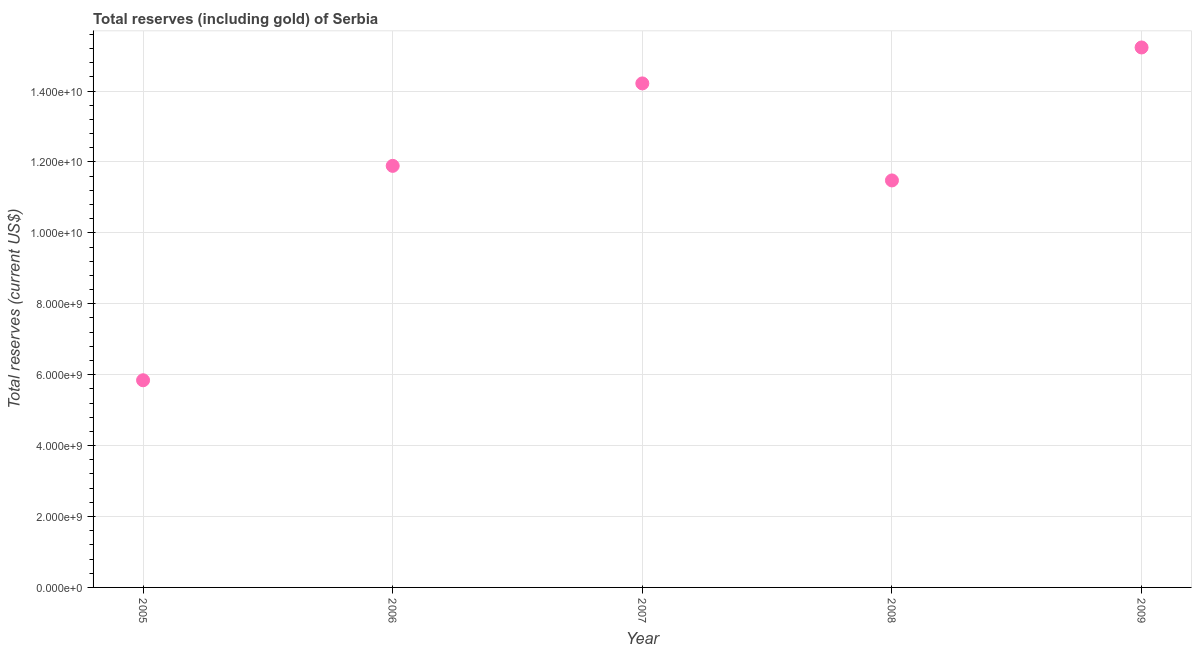What is the total reserves (including gold) in 2008?
Ensure brevity in your answer.  1.15e+1. Across all years, what is the maximum total reserves (including gold)?
Your answer should be very brief. 1.52e+1. Across all years, what is the minimum total reserves (including gold)?
Your answer should be very brief. 5.84e+09. What is the sum of the total reserves (including gold)?
Offer a terse response. 5.87e+1. What is the difference between the total reserves (including gold) in 2006 and 2009?
Make the answer very short. -3.34e+09. What is the average total reserves (including gold) per year?
Offer a very short reply. 1.17e+1. What is the median total reserves (including gold)?
Your answer should be compact. 1.19e+1. What is the ratio of the total reserves (including gold) in 2005 to that in 2007?
Keep it short and to the point. 0.41. Is the total reserves (including gold) in 2007 less than that in 2008?
Your response must be concise. No. What is the difference between the highest and the second highest total reserves (including gold)?
Provide a short and direct response. 1.01e+09. What is the difference between the highest and the lowest total reserves (including gold)?
Provide a short and direct response. 9.39e+09. In how many years, is the total reserves (including gold) greater than the average total reserves (including gold) taken over all years?
Your answer should be very brief. 3. How many dotlines are there?
Keep it short and to the point. 1. Are the values on the major ticks of Y-axis written in scientific E-notation?
Provide a succinct answer. Yes. Does the graph contain grids?
Make the answer very short. Yes. What is the title of the graph?
Make the answer very short. Total reserves (including gold) of Serbia. What is the label or title of the Y-axis?
Offer a very short reply. Total reserves (current US$). What is the Total reserves (current US$) in 2005?
Offer a terse response. 5.84e+09. What is the Total reserves (current US$) in 2006?
Give a very brief answer. 1.19e+1. What is the Total reserves (current US$) in 2007?
Offer a very short reply. 1.42e+1. What is the Total reserves (current US$) in 2008?
Make the answer very short. 1.15e+1. What is the Total reserves (current US$) in 2009?
Provide a succinct answer. 1.52e+1. What is the difference between the Total reserves (current US$) in 2005 and 2006?
Offer a very short reply. -6.05e+09. What is the difference between the Total reserves (current US$) in 2005 and 2007?
Make the answer very short. -8.37e+09. What is the difference between the Total reserves (current US$) in 2005 and 2008?
Your answer should be compact. -5.64e+09. What is the difference between the Total reserves (current US$) in 2005 and 2009?
Make the answer very short. -9.39e+09. What is the difference between the Total reserves (current US$) in 2006 and 2007?
Your answer should be very brief. -2.33e+09. What is the difference between the Total reserves (current US$) in 2006 and 2008?
Provide a short and direct response. 4.11e+08. What is the difference between the Total reserves (current US$) in 2006 and 2009?
Your answer should be compact. -3.34e+09. What is the difference between the Total reserves (current US$) in 2007 and 2008?
Ensure brevity in your answer.  2.74e+09. What is the difference between the Total reserves (current US$) in 2007 and 2009?
Your answer should be very brief. -1.01e+09. What is the difference between the Total reserves (current US$) in 2008 and 2009?
Offer a terse response. -3.75e+09. What is the ratio of the Total reserves (current US$) in 2005 to that in 2006?
Offer a terse response. 0.49. What is the ratio of the Total reserves (current US$) in 2005 to that in 2007?
Your response must be concise. 0.41. What is the ratio of the Total reserves (current US$) in 2005 to that in 2008?
Make the answer very short. 0.51. What is the ratio of the Total reserves (current US$) in 2005 to that in 2009?
Offer a terse response. 0.38. What is the ratio of the Total reserves (current US$) in 2006 to that in 2007?
Make the answer very short. 0.84. What is the ratio of the Total reserves (current US$) in 2006 to that in 2008?
Your response must be concise. 1.04. What is the ratio of the Total reserves (current US$) in 2006 to that in 2009?
Make the answer very short. 0.78. What is the ratio of the Total reserves (current US$) in 2007 to that in 2008?
Offer a terse response. 1.24. What is the ratio of the Total reserves (current US$) in 2007 to that in 2009?
Keep it short and to the point. 0.93. What is the ratio of the Total reserves (current US$) in 2008 to that in 2009?
Provide a succinct answer. 0.75. 